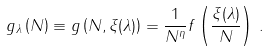Convert formula to latex. <formula><loc_0><loc_0><loc_500><loc_500>g _ { \lambda } \left ( N \right ) \equiv g \left ( N , \xi ( \lambda ) \right ) = \frac { 1 } { N ^ { \eta } } f \left ( \frac { \xi ( \lambda ) } { N } \right ) \, .</formula> 